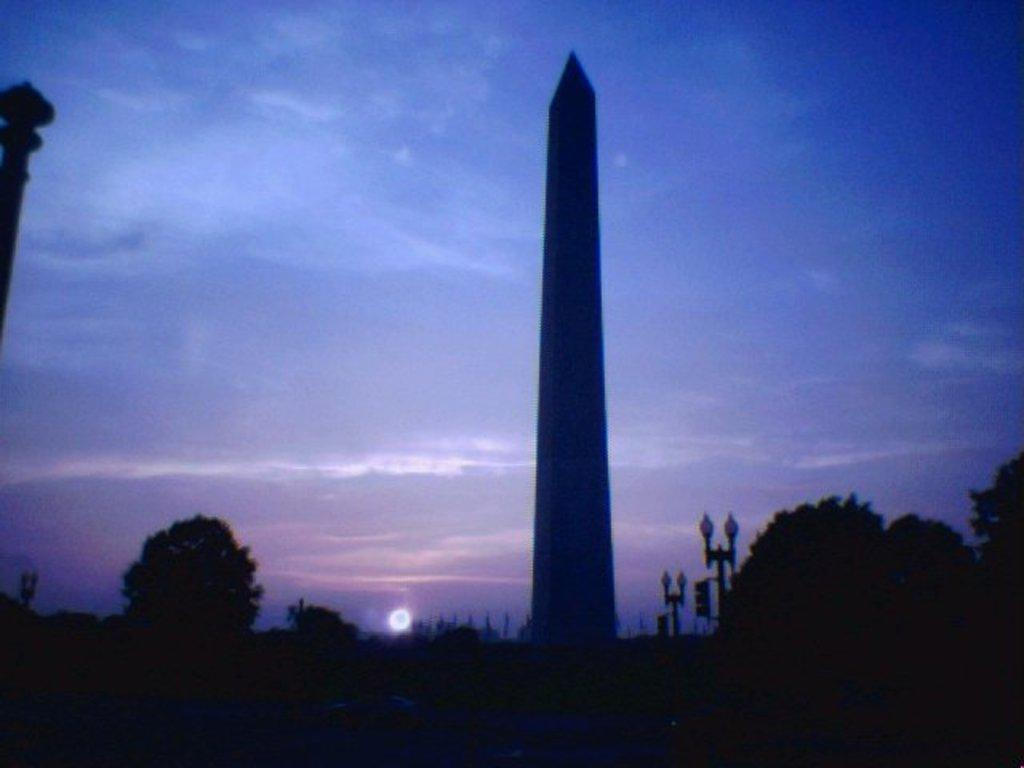What is the main structure in the image? There is a tower in the image. What other objects can be seen in the image? There are trees and light poles visible in the image. What is visible in the background of the image? The sky is visible in the background of the image. What type of reward is hanging from the trees in the image? There are no rewards hanging from the trees in the image; only trees and light poles are present. 